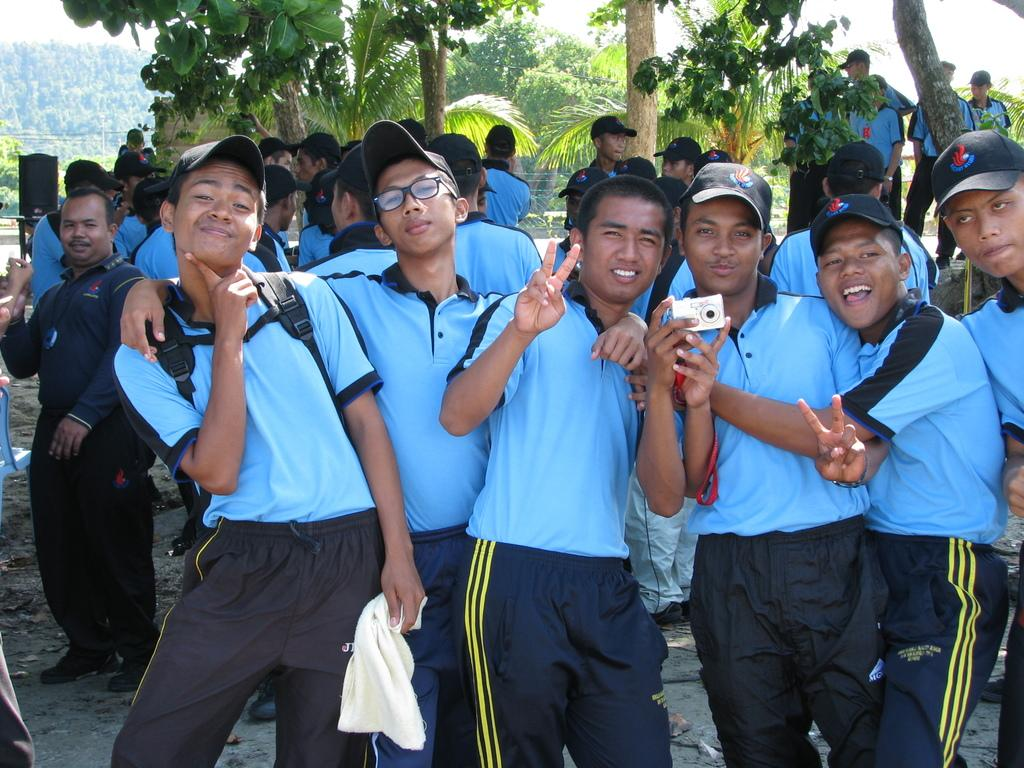Who is present in the image? There are people in the image. What is the man holding in the image? The man is holding a camera. What type of natural environment can be seen in the image? There are trees in the image. What is visible in the background of the image? The sky is visible in the background of the image. What type of cushion is the grandfather sitting on in the image? There is no grandfather or cushion present in the image. 